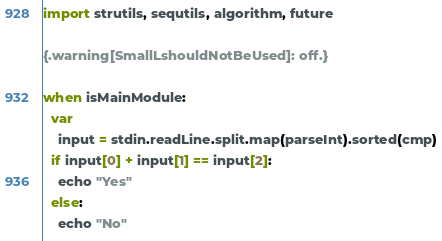<code> <loc_0><loc_0><loc_500><loc_500><_Nim_>import strutils, sequtils, algorithm, future

{.warning[SmallLshouldNotBeUsed]: off.}

when isMainModule:
  var
    input = stdin.readLine.split.map(parseInt).sorted(cmp)
  if input[0] + input[1] == input[2]:
    echo "Yes"
  else:
    echo "No"</code> 